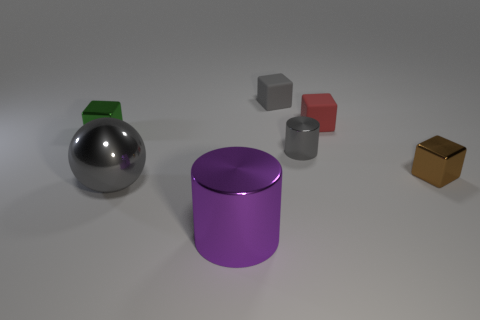Is there anything else that is the same color as the metallic ball?
Your answer should be compact. Yes. What is the size of the red object?
Your answer should be very brief. Small. Is the object that is on the left side of the big gray metal sphere made of the same material as the tiny gray cube?
Ensure brevity in your answer.  No. Do the gray matte object and the red matte object have the same shape?
Offer a very short reply. Yes. There is a gray thing that is behind the metal object that is behind the shiny cylinder behind the brown block; what is its shape?
Offer a very short reply. Cube. There is a rubber object left of the red block; is its shape the same as the small thing that is to the left of the gray shiny ball?
Your answer should be compact. Yes. Are there any balls that have the same material as the tiny gray block?
Offer a terse response. No. The tiny shiny cube that is left of the big gray metallic ball that is on the left side of the metallic cylinder that is behind the big gray shiny object is what color?
Ensure brevity in your answer.  Green. Does the small gray block that is left of the red rubber object have the same material as the large gray ball that is in front of the gray cylinder?
Provide a succinct answer. No. There is a big metal thing that is on the left side of the big shiny cylinder; what shape is it?
Ensure brevity in your answer.  Sphere. 